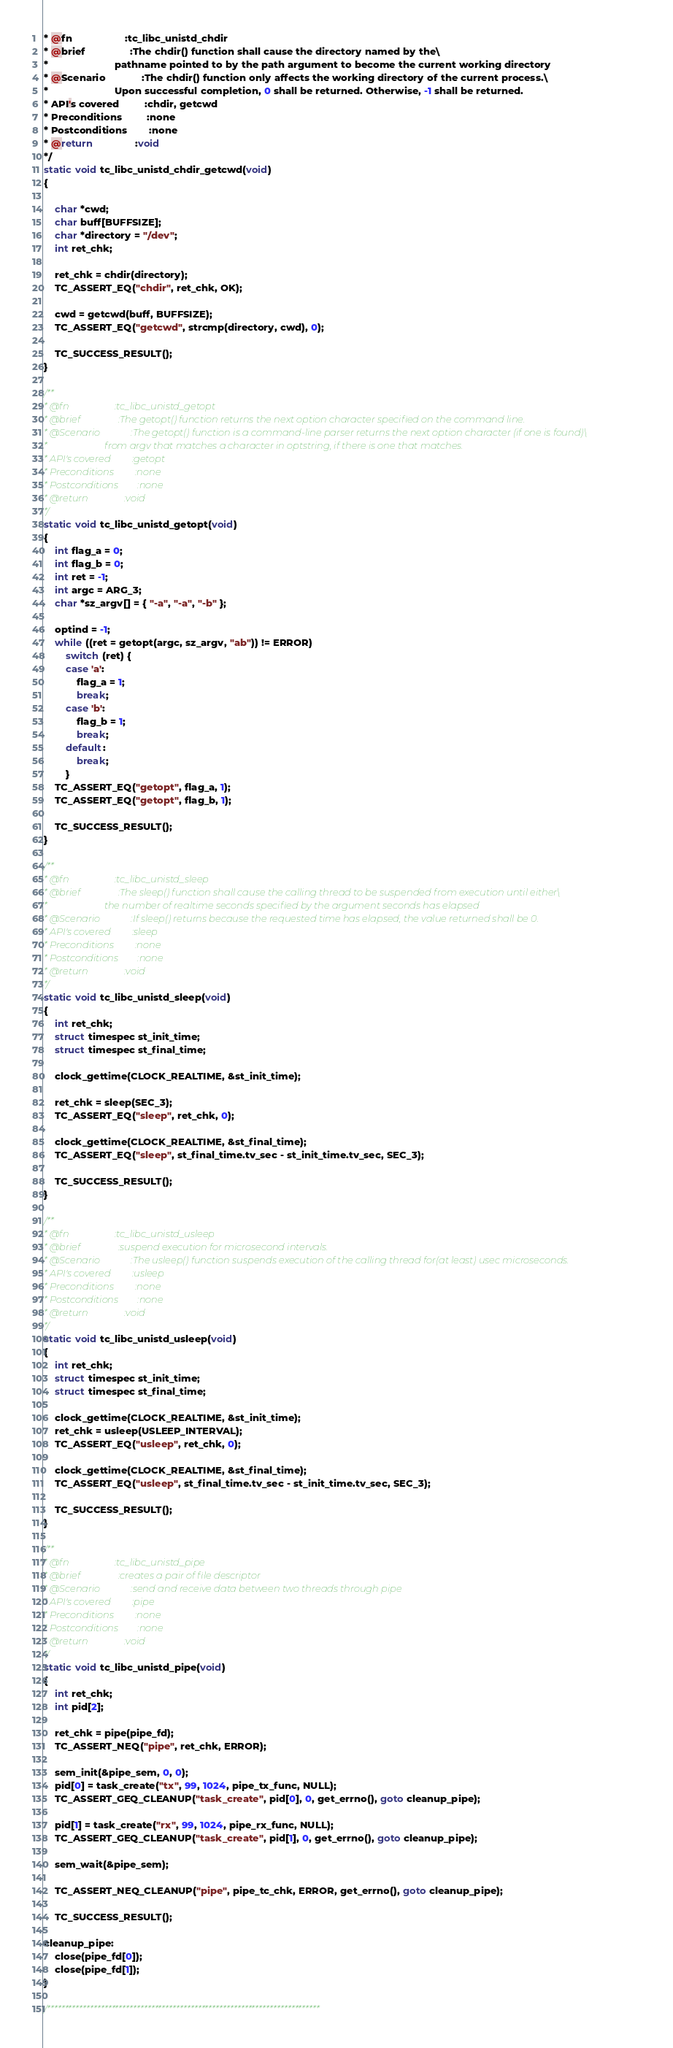Convert code to text. <code><loc_0><loc_0><loc_500><loc_500><_C_>* @fn                   :tc_libc_unistd_chdir
* @brief                :The chdir() function shall cause the directory named by the\
*                        pathname pointed to by the path argument to become the current working directory
* @Scenario             :The chdir() function only affects the working directory of the current process.\
*                        Upon successful completion, 0 shall be returned. Otherwise, -1 shall be returned.
* API's covered         :chdir, getcwd
* Preconditions         :none
* Postconditions        :none
* @return               :void
*/
static void tc_libc_unistd_chdir_getcwd(void)
{

	char *cwd;
	char buff[BUFFSIZE];
	char *directory = "/dev";
	int ret_chk;

	ret_chk = chdir(directory);
	TC_ASSERT_EQ("chdir", ret_chk, OK);

	cwd = getcwd(buff, BUFFSIZE);
	TC_ASSERT_EQ("getcwd", strcmp(directory, cwd), 0);

	TC_SUCCESS_RESULT();
}

/**
* @fn                   :tc_libc_unistd_getopt
* @brief                :The getopt() function returns the next option character specified on the command line.
* @Scenario             :The getopt() function is a command-line parser returns the next option character (if one is found)\
*                        from argv that matches a character in optstring, if there is one that matches.
* API's covered         :getopt
* Preconditions         :none
* Postconditions        :none
* @return               :void
*/
static void tc_libc_unistd_getopt(void)
{
	int flag_a = 0;
	int flag_b = 0;
	int ret = -1;
	int argc = ARG_3;
	char *sz_argv[] = { "-a", "-a", "-b" };

	optind = -1;
	while ((ret = getopt(argc, sz_argv, "ab")) != ERROR)
		switch (ret) {
		case 'a':
			flag_a = 1;
			break;
		case 'b':
			flag_b = 1;
			break;
		default:
			break;
		}
	TC_ASSERT_EQ("getopt", flag_a, 1);
	TC_ASSERT_EQ("getopt", flag_b, 1);

	TC_SUCCESS_RESULT();
}

/**
* @fn                   :tc_libc_unistd_sleep
* @brief                :The sleep() function shall cause the calling thread to be suspended from execution until either\
*                        the number of realtime seconds specified by the argument seconds has elapsed
* @Scenario             :If sleep() returns because the requested time has elapsed, the value returned shall be 0.
* API's covered         :sleep
* Preconditions         :none
* Postconditions        :none
* @return               :void
*/
static void tc_libc_unistd_sleep(void)
{
	int ret_chk;
	struct timespec st_init_time;
	struct timespec st_final_time;

	clock_gettime(CLOCK_REALTIME, &st_init_time);

	ret_chk = sleep(SEC_3);
	TC_ASSERT_EQ("sleep", ret_chk, 0);

	clock_gettime(CLOCK_REALTIME, &st_final_time);
	TC_ASSERT_EQ("sleep", st_final_time.tv_sec - st_init_time.tv_sec, SEC_3);

	TC_SUCCESS_RESULT();
}

/**
* @fn                   :tc_libc_unistd_usleep
* @brief                :suspend execution for microsecond intervals.
* @Scenario             :The usleep() function suspends execution of the calling thread for(at least) usec microseconds.
* API's covered         :usleep
* Preconditions         :none
* Postconditions        :none
* @return               :void
*/
static void tc_libc_unistd_usleep(void)
{
	int ret_chk;
	struct timespec st_init_time;
	struct timespec st_final_time;

	clock_gettime(CLOCK_REALTIME, &st_init_time);
	ret_chk = usleep(USLEEP_INTERVAL);
	TC_ASSERT_EQ("usleep", ret_chk, 0);

	clock_gettime(CLOCK_REALTIME, &st_final_time);
	TC_ASSERT_EQ("usleep", st_final_time.tv_sec - st_init_time.tv_sec, SEC_3);

	TC_SUCCESS_RESULT();
}

/**
* @fn                   :tc_libc_unistd_pipe
* @brief                :creates a pair of file descriptor
* @Scenario             :send and receive data between two threads through pipe
* API's covered         :pipe
* Preconditions         :none
* Postconditions        :none
* @return               :void
*/
static void tc_libc_unistd_pipe(void)
{
	int ret_chk;
	int pid[2];

	ret_chk = pipe(pipe_fd);
	TC_ASSERT_NEQ("pipe", ret_chk, ERROR);

	sem_init(&pipe_sem, 0, 0);
	pid[0] = task_create("tx", 99, 1024, pipe_tx_func, NULL);
	TC_ASSERT_GEQ_CLEANUP("task_create", pid[0], 0, get_errno(), goto cleanup_pipe);

	pid[1] = task_create("rx", 99, 1024, pipe_rx_func, NULL);
	TC_ASSERT_GEQ_CLEANUP("task_create", pid[1], 0, get_errno(), goto cleanup_pipe);

	sem_wait(&pipe_sem);

	TC_ASSERT_NEQ_CLEANUP("pipe", pipe_tc_chk, ERROR, get_errno(), goto cleanup_pipe);

	TC_SUCCESS_RESULT();

cleanup_pipe:
	close(pipe_fd[0]);
	close(pipe_fd[1]);
}

/****************************************************************************</code> 